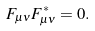Convert formula to latex. <formula><loc_0><loc_0><loc_500><loc_500>F _ { \mu \nu } F _ { \mu \nu } ^ { * } = 0 .</formula> 